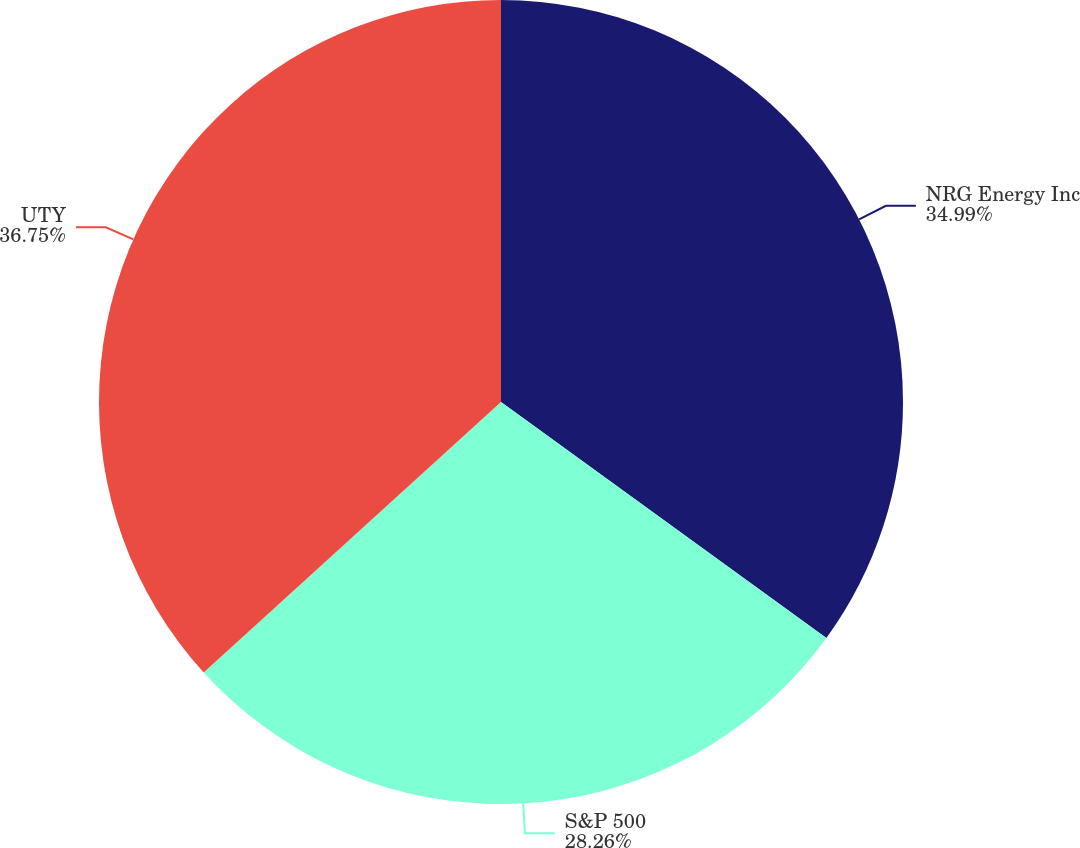Convert chart. <chart><loc_0><loc_0><loc_500><loc_500><pie_chart><fcel>NRG Energy Inc<fcel>S&P 500<fcel>UTY<nl><fcel>34.99%<fcel>28.26%<fcel>36.75%<nl></chart> 